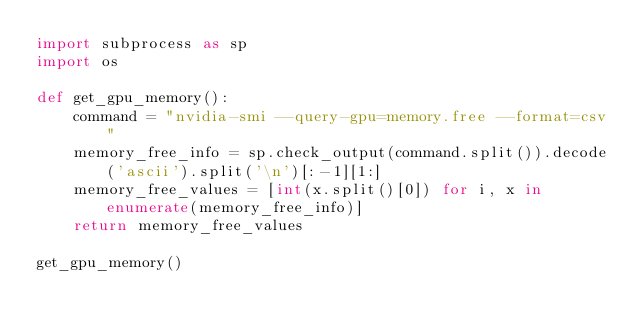Convert code to text. <code><loc_0><loc_0><loc_500><loc_500><_Python_>import subprocess as sp
import os

def get_gpu_memory():
    command = "nvidia-smi --query-gpu=memory.free --format=csv"
    memory_free_info = sp.check_output(command.split()).decode('ascii').split('\n')[:-1][1:]
    memory_free_values = [int(x.split()[0]) for i, x in enumerate(memory_free_info)]
    return memory_free_values

get_gpu_memory()
</code> 